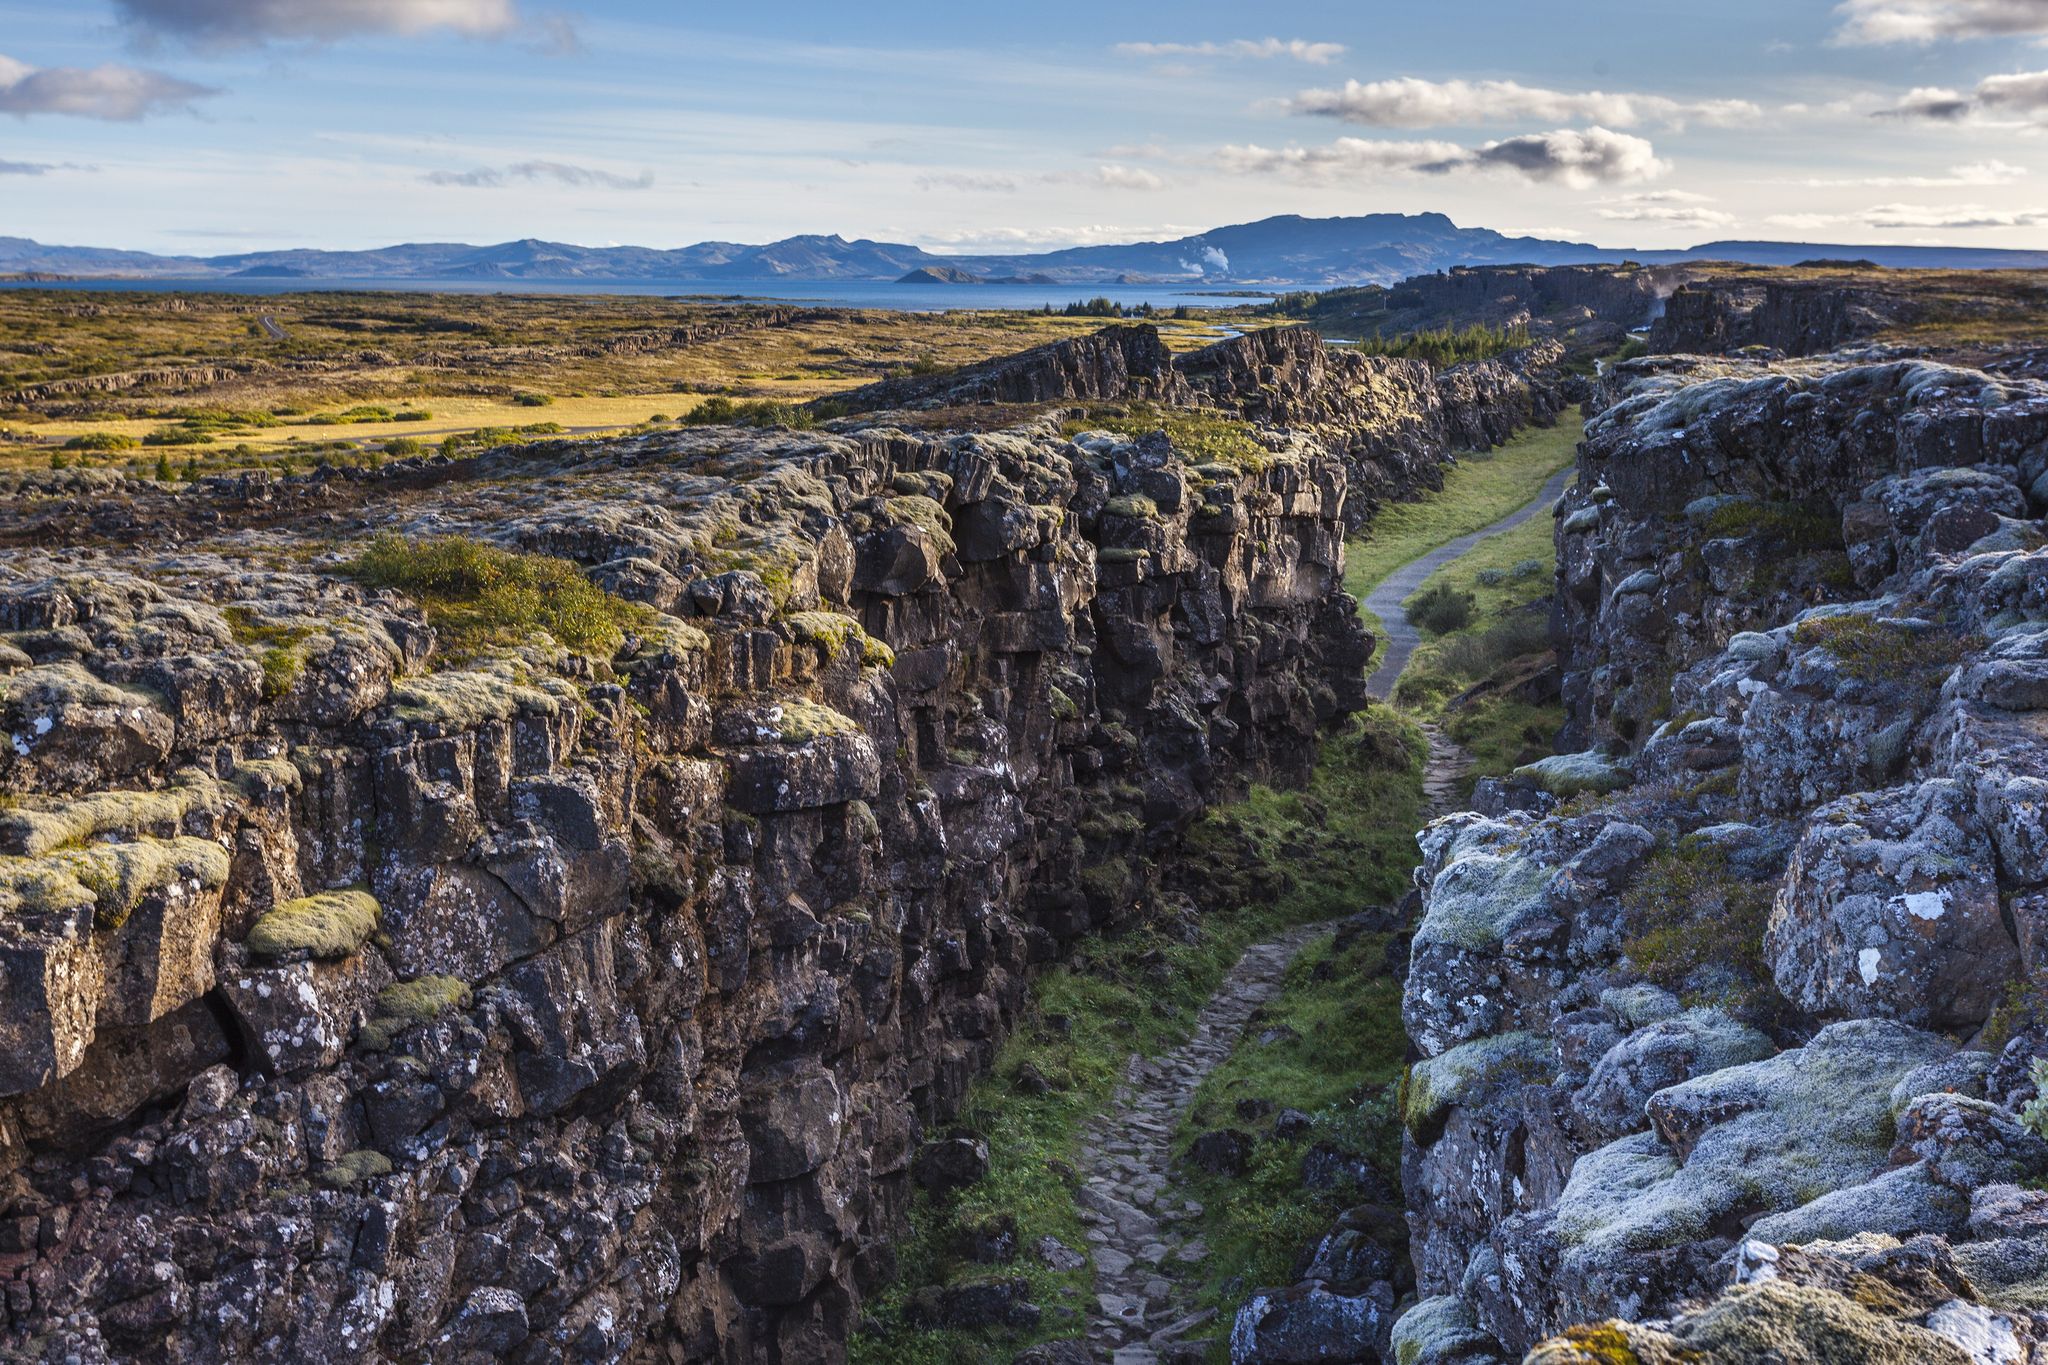Imagine if Þingvellir National Park had mythical creatures living in its gorge. Describe what it might be like. Imagine Þingvellir National Park as the ancient home of majestic dragons. These creatures, with scales shimmering in shades of green and gold, blend perfectly with the moss-covered cliffs. As one strolls along the path in the gorge, the air hums with the low, melodic growls of dragons conversing. In the serenity of the lake, dragons could be seen soaring gracefully, their reflections dancing on the water's surface. The park transforms into a mystical realm where every corner holds a tale of legends and adventures. 